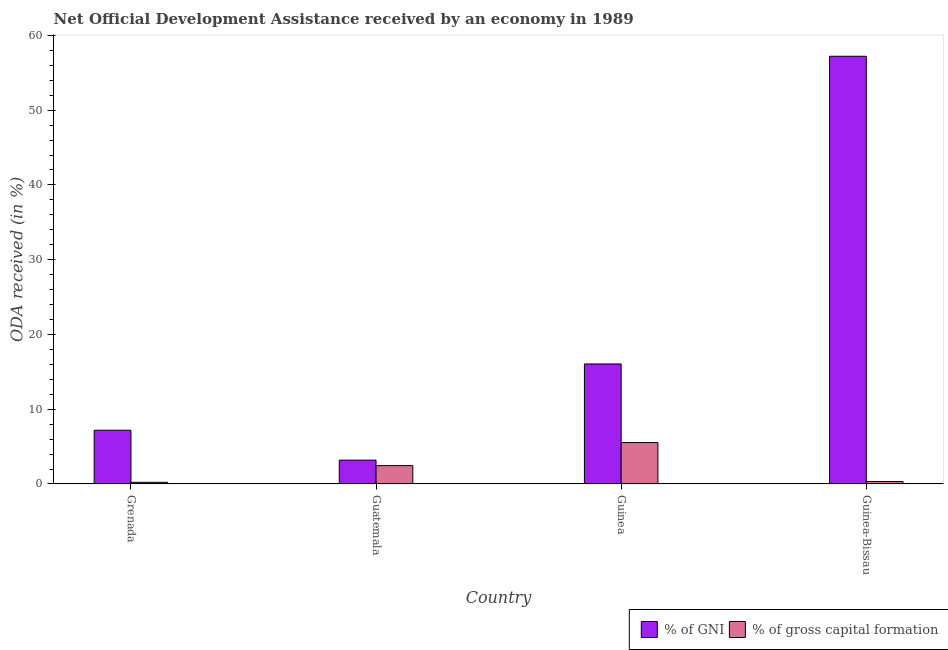Are the number of bars on each tick of the X-axis equal?
Make the answer very short. Yes. How many bars are there on the 3rd tick from the left?
Ensure brevity in your answer.  2. What is the label of the 4th group of bars from the left?
Offer a very short reply. Guinea-Bissau. What is the oda received as percentage of gross capital formation in Guinea?
Keep it short and to the point. 5.54. Across all countries, what is the maximum oda received as percentage of gross capital formation?
Your answer should be very brief. 5.54. Across all countries, what is the minimum oda received as percentage of gni?
Your answer should be compact. 3.19. In which country was the oda received as percentage of gross capital formation maximum?
Your response must be concise. Guinea. In which country was the oda received as percentage of gni minimum?
Your answer should be very brief. Guatemala. What is the total oda received as percentage of gross capital formation in the graph?
Provide a succinct answer. 8.55. What is the difference between the oda received as percentage of gni in Guatemala and that in Guinea-Bissau?
Your answer should be very brief. -54.02. What is the difference between the oda received as percentage of gross capital formation in Guinea-Bissau and the oda received as percentage of gni in Guatemala?
Provide a succinct answer. -2.86. What is the average oda received as percentage of gross capital formation per country?
Make the answer very short. 2.14. What is the difference between the oda received as percentage of gross capital formation and oda received as percentage of gni in Guatemala?
Your answer should be compact. -0.73. In how many countries, is the oda received as percentage of gni greater than 6 %?
Make the answer very short. 3. What is the ratio of the oda received as percentage of gni in Guatemala to that in Guinea-Bissau?
Ensure brevity in your answer.  0.06. Is the oda received as percentage of gni in Guinea less than that in Guinea-Bissau?
Keep it short and to the point. Yes. Is the difference between the oda received as percentage of gross capital formation in Grenada and Guinea-Bissau greater than the difference between the oda received as percentage of gni in Grenada and Guinea-Bissau?
Offer a very short reply. Yes. What is the difference between the highest and the second highest oda received as percentage of gross capital formation?
Your response must be concise. 3.08. What is the difference between the highest and the lowest oda received as percentage of gni?
Your response must be concise. 54.02. In how many countries, is the oda received as percentage of gross capital formation greater than the average oda received as percentage of gross capital formation taken over all countries?
Your answer should be compact. 2. What does the 1st bar from the left in Guatemala represents?
Make the answer very short. % of GNI. What does the 2nd bar from the right in Guinea represents?
Ensure brevity in your answer.  % of GNI. Where does the legend appear in the graph?
Your answer should be compact. Bottom right. How are the legend labels stacked?
Your answer should be compact. Horizontal. What is the title of the graph?
Keep it short and to the point. Net Official Development Assistance received by an economy in 1989. Does "Mobile cellular" appear as one of the legend labels in the graph?
Provide a short and direct response. No. What is the label or title of the X-axis?
Provide a short and direct response. Country. What is the label or title of the Y-axis?
Offer a terse response. ODA received (in %). What is the ODA received (in %) of % of GNI in Grenada?
Provide a short and direct response. 7.19. What is the ODA received (in %) of % of gross capital formation in Grenada?
Offer a terse response. 0.22. What is the ODA received (in %) of % of GNI in Guatemala?
Keep it short and to the point. 3.19. What is the ODA received (in %) in % of gross capital formation in Guatemala?
Make the answer very short. 2.46. What is the ODA received (in %) of % of GNI in Guinea?
Provide a succinct answer. 16.05. What is the ODA received (in %) in % of gross capital formation in Guinea?
Provide a succinct answer. 5.54. What is the ODA received (in %) of % of GNI in Guinea-Bissau?
Offer a very short reply. 57.21. What is the ODA received (in %) in % of gross capital formation in Guinea-Bissau?
Provide a succinct answer. 0.33. Across all countries, what is the maximum ODA received (in %) in % of GNI?
Your answer should be compact. 57.21. Across all countries, what is the maximum ODA received (in %) in % of gross capital formation?
Ensure brevity in your answer.  5.54. Across all countries, what is the minimum ODA received (in %) of % of GNI?
Provide a short and direct response. 3.19. Across all countries, what is the minimum ODA received (in %) of % of gross capital formation?
Provide a short and direct response. 0.22. What is the total ODA received (in %) in % of GNI in the graph?
Offer a very short reply. 83.64. What is the total ODA received (in %) of % of gross capital formation in the graph?
Ensure brevity in your answer.  8.55. What is the difference between the ODA received (in %) of % of GNI in Grenada and that in Guatemala?
Offer a terse response. 4. What is the difference between the ODA received (in %) in % of gross capital formation in Grenada and that in Guatemala?
Keep it short and to the point. -2.23. What is the difference between the ODA received (in %) in % of GNI in Grenada and that in Guinea?
Give a very brief answer. -8.86. What is the difference between the ODA received (in %) of % of gross capital formation in Grenada and that in Guinea?
Your response must be concise. -5.32. What is the difference between the ODA received (in %) of % of GNI in Grenada and that in Guinea-Bissau?
Provide a short and direct response. -50.02. What is the difference between the ODA received (in %) in % of gross capital formation in Grenada and that in Guinea-Bissau?
Provide a short and direct response. -0.11. What is the difference between the ODA received (in %) in % of GNI in Guatemala and that in Guinea?
Provide a succinct answer. -12.87. What is the difference between the ODA received (in %) in % of gross capital formation in Guatemala and that in Guinea?
Offer a terse response. -3.08. What is the difference between the ODA received (in %) of % of GNI in Guatemala and that in Guinea-Bissau?
Your response must be concise. -54.02. What is the difference between the ODA received (in %) in % of gross capital formation in Guatemala and that in Guinea-Bissau?
Your response must be concise. 2.13. What is the difference between the ODA received (in %) of % of GNI in Guinea and that in Guinea-Bissau?
Provide a succinct answer. -41.15. What is the difference between the ODA received (in %) in % of gross capital formation in Guinea and that in Guinea-Bissau?
Ensure brevity in your answer.  5.21. What is the difference between the ODA received (in %) of % of GNI in Grenada and the ODA received (in %) of % of gross capital formation in Guatemala?
Provide a succinct answer. 4.73. What is the difference between the ODA received (in %) of % of GNI in Grenada and the ODA received (in %) of % of gross capital formation in Guinea?
Make the answer very short. 1.65. What is the difference between the ODA received (in %) of % of GNI in Grenada and the ODA received (in %) of % of gross capital formation in Guinea-Bissau?
Ensure brevity in your answer.  6.86. What is the difference between the ODA received (in %) in % of GNI in Guatemala and the ODA received (in %) in % of gross capital formation in Guinea?
Give a very brief answer. -2.35. What is the difference between the ODA received (in %) in % of GNI in Guatemala and the ODA received (in %) in % of gross capital formation in Guinea-Bissau?
Provide a short and direct response. 2.86. What is the difference between the ODA received (in %) of % of GNI in Guinea and the ODA received (in %) of % of gross capital formation in Guinea-Bissau?
Make the answer very short. 15.73. What is the average ODA received (in %) in % of GNI per country?
Your answer should be very brief. 20.91. What is the average ODA received (in %) of % of gross capital formation per country?
Make the answer very short. 2.14. What is the difference between the ODA received (in %) of % of GNI and ODA received (in %) of % of gross capital formation in Grenada?
Ensure brevity in your answer.  6.97. What is the difference between the ODA received (in %) of % of GNI and ODA received (in %) of % of gross capital formation in Guatemala?
Your response must be concise. 0.73. What is the difference between the ODA received (in %) in % of GNI and ODA received (in %) in % of gross capital formation in Guinea?
Ensure brevity in your answer.  10.51. What is the difference between the ODA received (in %) of % of GNI and ODA received (in %) of % of gross capital formation in Guinea-Bissau?
Provide a short and direct response. 56.88. What is the ratio of the ODA received (in %) in % of GNI in Grenada to that in Guatemala?
Keep it short and to the point. 2.26. What is the ratio of the ODA received (in %) of % of gross capital formation in Grenada to that in Guatemala?
Offer a very short reply. 0.09. What is the ratio of the ODA received (in %) in % of GNI in Grenada to that in Guinea?
Give a very brief answer. 0.45. What is the ratio of the ODA received (in %) of % of gross capital formation in Grenada to that in Guinea?
Ensure brevity in your answer.  0.04. What is the ratio of the ODA received (in %) in % of GNI in Grenada to that in Guinea-Bissau?
Keep it short and to the point. 0.13. What is the ratio of the ODA received (in %) of % of gross capital formation in Grenada to that in Guinea-Bissau?
Your response must be concise. 0.68. What is the ratio of the ODA received (in %) in % of GNI in Guatemala to that in Guinea?
Keep it short and to the point. 0.2. What is the ratio of the ODA received (in %) of % of gross capital formation in Guatemala to that in Guinea?
Your answer should be very brief. 0.44. What is the ratio of the ODA received (in %) of % of GNI in Guatemala to that in Guinea-Bissau?
Make the answer very short. 0.06. What is the ratio of the ODA received (in %) of % of gross capital formation in Guatemala to that in Guinea-Bissau?
Make the answer very short. 7.47. What is the ratio of the ODA received (in %) in % of GNI in Guinea to that in Guinea-Bissau?
Provide a succinct answer. 0.28. What is the ratio of the ODA received (in %) of % of gross capital formation in Guinea to that in Guinea-Bissau?
Ensure brevity in your answer.  16.86. What is the difference between the highest and the second highest ODA received (in %) in % of GNI?
Your answer should be compact. 41.15. What is the difference between the highest and the second highest ODA received (in %) in % of gross capital formation?
Make the answer very short. 3.08. What is the difference between the highest and the lowest ODA received (in %) of % of GNI?
Keep it short and to the point. 54.02. What is the difference between the highest and the lowest ODA received (in %) in % of gross capital formation?
Your answer should be compact. 5.32. 